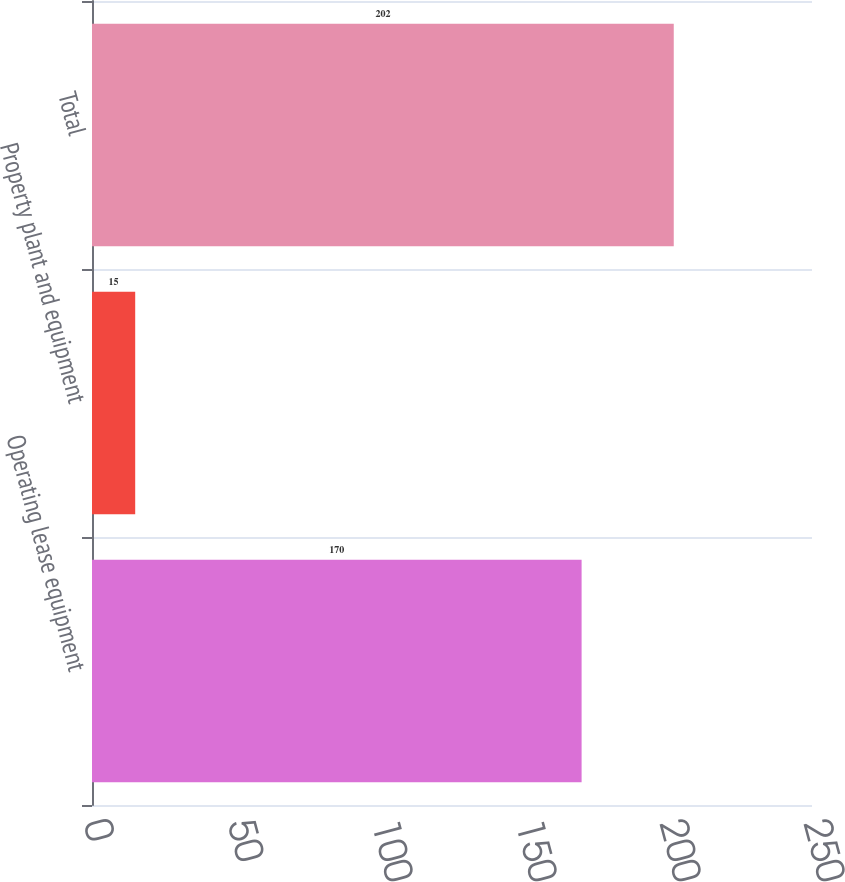<chart> <loc_0><loc_0><loc_500><loc_500><bar_chart><fcel>Operating lease equipment<fcel>Property plant and equipment<fcel>Total<nl><fcel>170<fcel>15<fcel>202<nl></chart> 